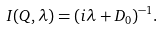<formula> <loc_0><loc_0><loc_500><loc_500>I ( Q , \lambda ) = ( i \lambda + D _ { 0 } ) ^ { - 1 } .</formula> 